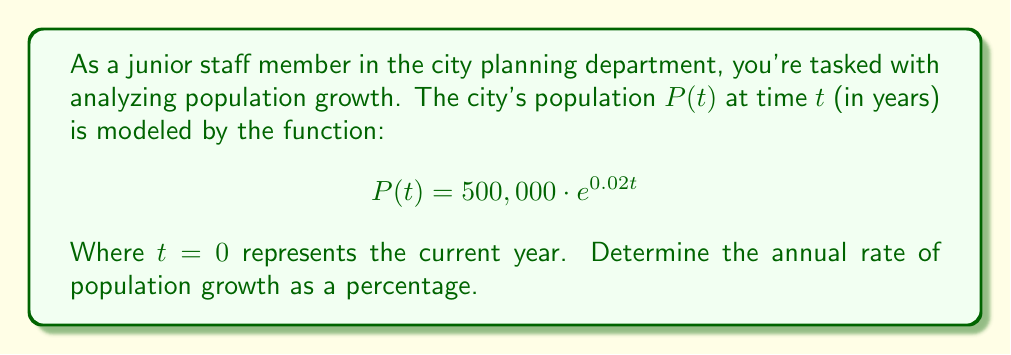Can you solve this math problem? To find the annual rate of population growth, we need to analyze the given function:

$$ P(t) = 500,000 \cdot e^{0.02t} $$

1) This function is in the form of an exponential growth model:
   $$ P(t) = P_0 \cdot e^{rt} $$
   Where $P_0$ is the initial population and $r$ is the growth rate.

2) In our case:
   $P_0 = 500,000$ (initial population)
   $r = 0.02$ (growth rate)

3) The growth rate $r$ in an exponential model represents the continuous growth rate.

4) To convert this to an annual percentage growth rate, we use the formula:
   $$ \text{Annual Growth Rate} = (e^r - 1) \times 100\% $$

5) Plugging in our $r$ value:
   $$ \text{Annual Growth Rate} = (e^{0.02} - 1) \times 100\% $$

6) Calculate:
   $$ \text{Annual Growth Rate} = (1.0202 - 1) \times 100\% = 0.0202 \times 100\% = 2.02\% $$
Answer: 2.02% 